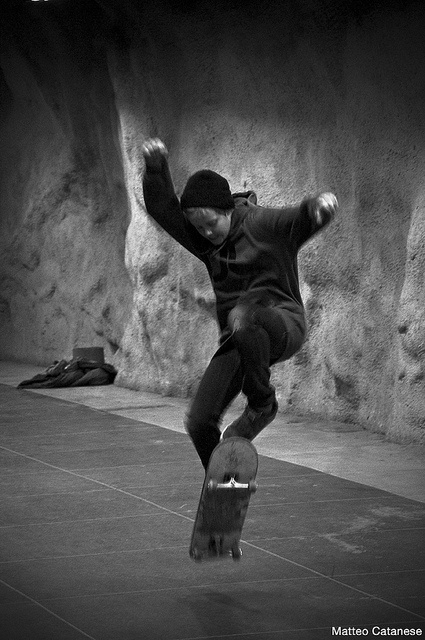Describe the objects in this image and their specific colors. I can see people in black, gray, darkgray, and lightgray tones, skateboard in black, gray, darkgray, and lightgray tones, and backpack in black, gray, and lightgray tones in this image. 